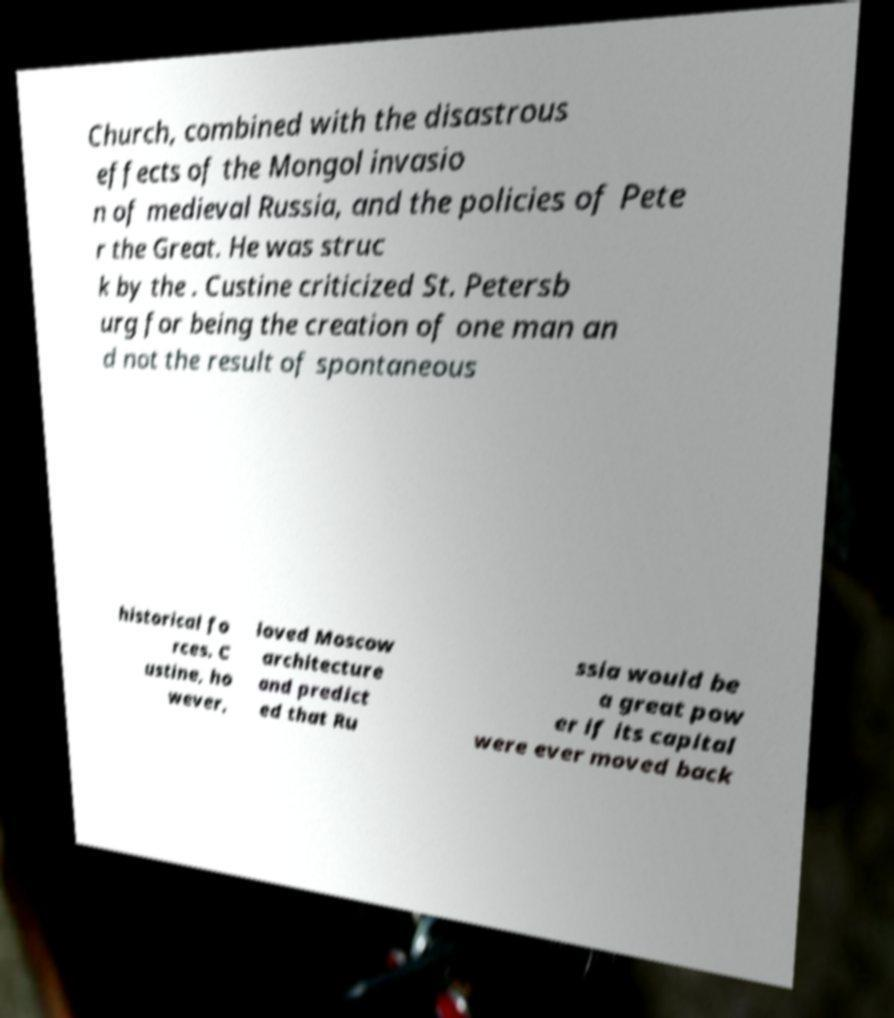For documentation purposes, I need the text within this image transcribed. Could you provide that? Church, combined with the disastrous effects of the Mongol invasio n of medieval Russia, and the policies of Pete r the Great. He was struc k by the . Custine criticized St. Petersb urg for being the creation of one man an d not the result of spontaneous historical fo rces. C ustine, ho wever, loved Moscow architecture and predict ed that Ru ssia would be a great pow er if its capital were ever moved back 